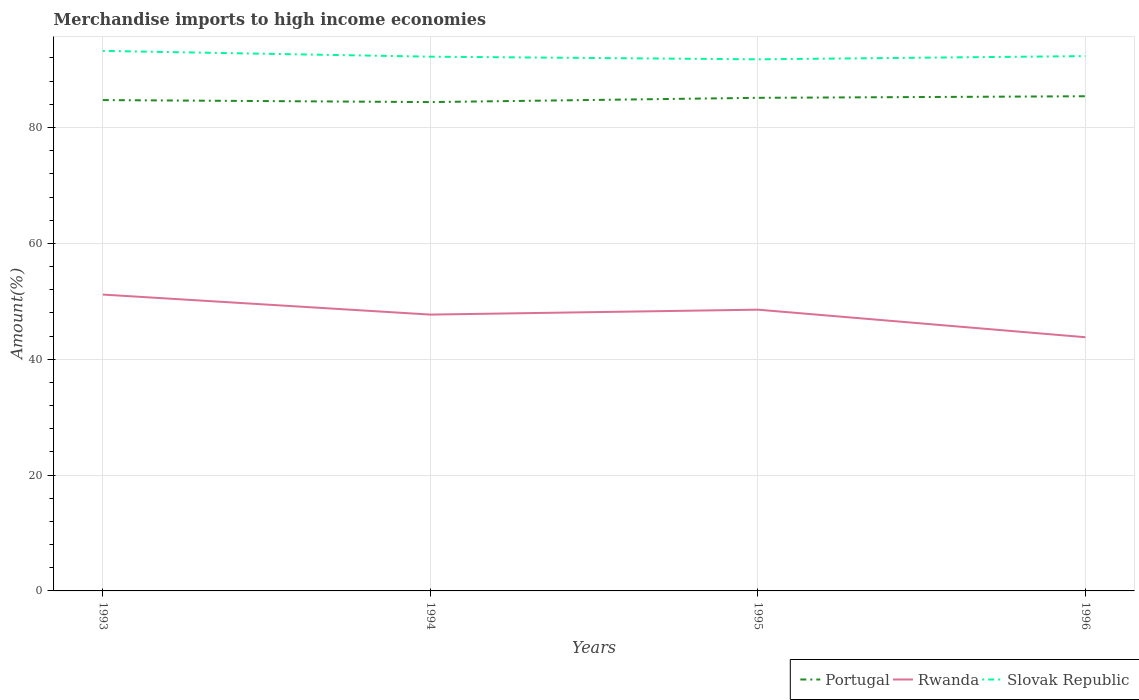Across all years, what is the maximum percentage of amount earned from merchandise imports in Slovak Republic?
Your answer should be very brief. 91.77. In which year was the percentage of amount earned from merchandise imports in Rwanda maximum?
Keep it short and to the point. 1996. What is the total percentage of amount earned from merchandise imports in Rwanda in the graph?
Give a very brief answer. 3.91. What is the difference between the highest and the second highest percentage of amount earned from merchandise imports in Slovak Republic?
Offer a terse response. 1.46. What is the difference between the highest and the lowest percentage of amount earned from merchandise imports in Portugal?
Provide a succinct answer. 2. Is the percentage of amount earned from merchandise imports in Rwanda strictly greater than the percentage of amount earned from merchandise imports in Portugal over the years?
Your response must be concise. Yes. How many lines are there?
Your response must be concise. 3. How many years are there in the graph?
Provide a succinct answer. 4. Are the values on the major ticks of Y-axis written in scientific E-notation?
Offer a terse response. No. Does the graph contain any zero values?
Offer a very short reply. No. Does the graph contain grids?
Keep it short and to the point. Yes. Where does the legend appear in the graph?
Offer a terse response. Bottom right. What is the title of the graph?
Provide a succinct answer. Merchandise imports to high income economies. Does "Bosnia and Herzegovina" appear as one of the legend labels in the graph?
Make the answer very short. No. What is the label or title of the X-axis?
Make the answer very short. Years. What is the label or title of the Y-axis?
Offer a terse response. Amount(%). What is the Amount(%) in Portugal in 1993?
Give a very brief answer. 84.74. What is the Amount(%) of Rwanda in 1993?
Give a very brief answer. 51.16. What is the Amount(%) of Slovak Republic in 1993?
Your answer should be very brief. 93.23. What is the Amount(%) in Portugal in 1994?
Your response must be concise. 84.39. What is the Amount(%) of Rwanda in 1994?
Offer a terse response. 47.7. What is the Amount(%) in Slovak Republic in 1994?
Your response must be concise. 92.23. What is the Amount(%) in Portugal in 1995?
Offer a very short reply. 85.12. What is the Amount(%) in Rwanda in 1995?
Your response must be concise. 48.55. What is the Amount(%) of Slovak Republic in 1995?
Your answer should be compact. 91.77. What is the Amount(%) of Portugal in 1996?
Make the answer very short. 85.39. What is the Amount(%) of Rwanda in 1996?
Provide a succinct answer. 43.8. What is the Amount(%) in Slovak Republic in 1996?
Your response must be concise. 92.33. Across all years, what is the maximum Amount(%) in Portugal?
Offer a very short reply. 85.39. Across all years, what is the maximum Amount(%) in Rwanda?
Offer a very short reply. 51.16. Across all years, what is the maximum Amount(%) in Slovak Republic?
Keep it short and to the point. 93.23. Across all years, what is the minimum Amount(%) of Portugal?
Provide a succinct answer. 84.39. Across all years, what is the minimum Amount(%) of Rwanda?
Offer a very short reply. 43.8. Across all years, what is the minimum Amount(%) in Slovak Republic?
Your response must be concise. 91.77. What is the total Amount(%) of Portugal in the graph?
Make the answer very short. 339.64. What is the total Amount(%) of Rwanda in the graph?
Make the answer very short. 191.21. What is the total Amount(%) of Slovak Republic in the graph?
Provide a short and direct response. 369.55. What is the difference between the Amount(%) in Portugal in 1993 and that in 1994?
Provide a short and direct response. 0.35. What is the difference between the Amount(%) in Rwanda in 1993 and that in 1994?
Provide a succinct answer. 3.46. What is the difference between the Amount(%) of Slovak Republic in 1993 and that in 1994?
Offer a very short reply. 1. What is the difference between the Amount(%) of Portugal in 1993 and that in 1995?
Your response must be concise. -0.39. What is the difference between the Amount(%) in Rwanda in 1993 and that in 1995?
Your response must be concise. 2.61. What is the difference between the Amount(%) of Slovak Republic in 1993 and that in 1995?
Ensure brevity in your answer.  1.46. What is the difference between the Amount(%) of Portugal in 1993 and that in 1996?
Keep it short and to the point. -0.66. What is the difference between the Amount(%) of Rwanda in 1993 and that in 1996?
Provide a short and direct response. 7.36. What is the difference between the Amount(%) in Slovak Republic in 1993 and that in 1996?
Give a very brief answer. 0.9. What is the difference between the Amount(%) in Portugal in 1994 and that in 1995?
Give a very brief answer. -0.74. What is the difference between the Amount(%) in Rwanda in 1994 and that in 1995?
Make the answer very short. -0.85. What is the difference between the Amount(%) of Slovak Republic in 1994 and that in 1995?
Ensure brevity in your answer.  0.46. What is the difference between the Amount(%) in Portugal in 1994 and that in 1996?
Ensure brevity in your answer.  -1.01. What is the difference between the Amount(%) of Rwanda in 1994 and that in 1996?
Provide a succinct answer. 3.91. What is the difference between the Amount(%) in Slovak Republic in 1994 and that in 1996?
Keep it short and to the point. -0.1. What is the difference between the Amount(%) of Portugal in 1995 and that in 1996?
Offer a very short reply. -0.27. What is the difference between the Amount(%) of Rwanda in 1995 and that in 1996?
Ensure brevity in your answer.  4.76. What is the difference between the Amount(%) of Slovak Republic in 1995 and that in 1996?
Offer a very short reply. -0.56. What is the difference between the Amount(%) of Portugal in 1993 and the Amount(%) of Rwanda in 1994?
Keep it short and to the point. 37.03. What is the difference between the Amount(%) in Portugal in 1993 and the Amount(%) in Slovak Republic in 1994?
Make the answer very short. -7.49. What is the difference between the Amount(%) of Rwanda in 1993 and the Amount(%) of Slovak Republic in 1994?
Offer a very short reply. -41.07. What is the difference between the Amount(%) of Portugal in 1993 and the Amount(%) of Rwanda in 1995?
Offer a terse response. 36.18. What is the difference between the Amount(%) of Portugal in 1993 and the Amount(%) of Slovak Republic in 1995?
Offer a terse response. -7.03. What is the difference between the Amount(%) in Rwanda in 1993 and the Amount(%) in Slovak Republic in 1995?
Offer a terse response. -40.61. What is the difference between the Amount(%) of Portugal in 1993 and the Amount(%) of Rwanda in 1996?
Give a very brief answer. 40.94. What is the difference between the Amount(%) in Portugal in 1993 and the Amount(%) in Slovak Republic in 1996?
Your answer should be very brief. -7.59. What is the difference between the Amount(%) in Rwanda in 1993 and the Amount(%) in Slovak Republic in 1996?
Offer a terse response. -41.17. What is the difference between the Amount(%) of Portugal in 1994 and the Amount(%) of Rwanda in 1995?
Your answer should be very brief. 35.84. What is the difference between the Amount(%) in Portugal in 1994 and the Amount(%) in Slovak Republic in 1995?
Give a very brief answer. -7.38. What is the difference between the Amount(%) of Rwanda in 1994 and the Amount(%) of Slovak Republic in 1995?
Provide a short and direct response. -44.07. What is the difference between the Amount(%) in Portugal in 1994 and the Amount(%) in Rwanda in 1996?
Provide a succinct answer. 40.59. What is the difference between the Amount(%) in Portugal in 1994 and the Amount(%) in Slovak Republic in 1996?
Offer a terse response. -7.94. What is the difference between the Amount(%) in Rwanda in 1994 and the Amount(%) in Slovak Republic in 1996?
Keep it short and to the point. -44.63. What is the difference between the Amount(%) of Portugal in 1995 and the Amount(%) of Rwanda in 1996?
Provide a succinct answer. 41.33. What is the difference between the Amount(%) in Portugal in 1995 and the Amount(%) in Slovak Republic in 1996?
Keep it short and to the point. -7.2. What is the difference between the Amount(%) in Rwanda in 1995 and the Amount(%) in Slovak Republic in 1996?
Make the answer very short. -43.78. What is the average Amount(%) of Portugal per year?
Make the answer very short. 84.91. What is the average Amount(%) of Rwanda per year?
Ensure brevity in your answer.  47.8. What is the average Amount(%) in Slovak Republic per year?
Provide a short and direct response. 92.39. In the year 1993, what is the difference between the Amount(%) of Portugal and Amount(%) of Rwanda?
Make the answer very short. 33.58. In the year 1993, what is the difference between the Amount(%) in Portugal and Amount(%) in Slovak Republic?
Offer a very short reply. -8.49. In the year 1993, what is the difference between the Amount(%) of Rwanda and Amount(%) of Slovak Republic?
Provide a short and direct response. -42.07. In the year 1994, what is the difference between the Amount(%) in Portugal and Amount(%) in Rwanda?
Make the answer very short. 36.69. In the year 1994, what is the difference between the Amount(%) of Portugal and Amount(%) of Slovak Republic?
Your response must be concise. -7.84. In the year 1994, what is the difference between the Amount(%) of Rwanda and Amount(%) of Slovak Republic?
Give a very brief answer. -44.52. In the year 1995, what is the difference between the Amount(%) in Portugal and Amount(%) in Rwanda?
Your answer should be compact. 36.57. In the year 1995, what is the difference between the Amount(%) in Portugal and Amount(%) in Slovak Republic?
Your response must be concise. -6.65. In the year 1995, what is the difference between the Amount(%) in Rwanda and Amount(%) in Slovak Republic?
Ensure brevity in your answer.  -43.22. In the year 1996, what is the difference between the Amount(%) in Portugal and Amount(%) in Rwanda?
Provide a succinct answer. 41.6. In the year 1996, what is the difference between the Amount(%) of Portugal and Amount(%) of Slovak Republic?
Provide a short and direct response. -6.93. In the year 1996, what is the difference between the Amount(%) in Rwanda and Amount(%) in Slovak Republic?
Offer a very short reply. -48.53. What is the ratio of the Amount(%) of Portugal in 1993 to that in 1994?
Offer a very short reply. 1. What is the ratio of the Amount(%) in Rwanda in 1993 to that in 1994?
Offer a very short reply. 1.07. What is the ratio of the Amount(%) of Slovak Republic in 1993 to that in 1994?
Make the answer very short. 1.01. What is the ratio of the Amount(%) in Rwanda in 1993 to that in 1995?
Provide a short and direct response. 1.05. What is the ratio of the Amount(%) of Slovak Republic in 1993 to that in 1995?
Keep it short and to the point. 1.02. What is the ratio of the Amount(%) of Portugal in 1993 to that in 1996?
Make the answer very short. 0.99. What is the ratio of the Amount(%) of Rwanda in 1993 to that in 1996?
Offer a very short reply. 1.17. What is the ratio of the Amount(%) of Slovak Republic in 1993 to that in 1996?
Your answer should be very brief. 1.01. What is the ratio of the Amount(%) of Rwanda in 1994 to that in 1995?
Give a very brief answer. 0.98. What is the ratio of the Amount(%) in Slovak Republic in 1994 to that in 1995?
Keep it short and to the point. 1. What is the ratio of the Amount(%) in Rwanda in 1994 to that in 1996?
Provide a succinct answer. 1.09. What is the ratio of the Amount(%) in Portugal in 1995 to that in 1996?
Your response must be concise. 1. What is the ratio of the Amount(%) of Rwanda in 1995 to that in 1996?
Give a very brief answer. 1.11. What is the ratio of the Amount(%) of Slovak Republic in 1995 to that in 1996?
Provide a succinct answer. 0.99. What is the difference between the highest and the second highest Amount(%) in Portugal?
Make the answer very short. 0.27. What is the difference between the highest and the second highest Amount(%) of Rwanda?
Keep it short and to the point. 2.61. What is the difference between the highest and the second highest Amount(%) in Slovak Republic?
Ensure brevity in your answer.  0.9. What is the difference between the highest and the lowest Amount(%) in Portugal?
Make the answer very short. 1.01. What is the difference between the highest and the lowest Amount(%) of Rwanda?
Your answer should be very brief. 7.36. What is the difference between the highest and the lowest Amount(%) in Slovak Republic?
Ensure brevity in your answer.  1.46. 